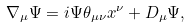<formula> <loc_0><loc_0><loc_500><loc_500>\nabla _ { \mu } \Psi = i \Psi \theta _ { \mu \nu } x ^ { \nu } + D _ { \mu } \Psi ,</formula> 